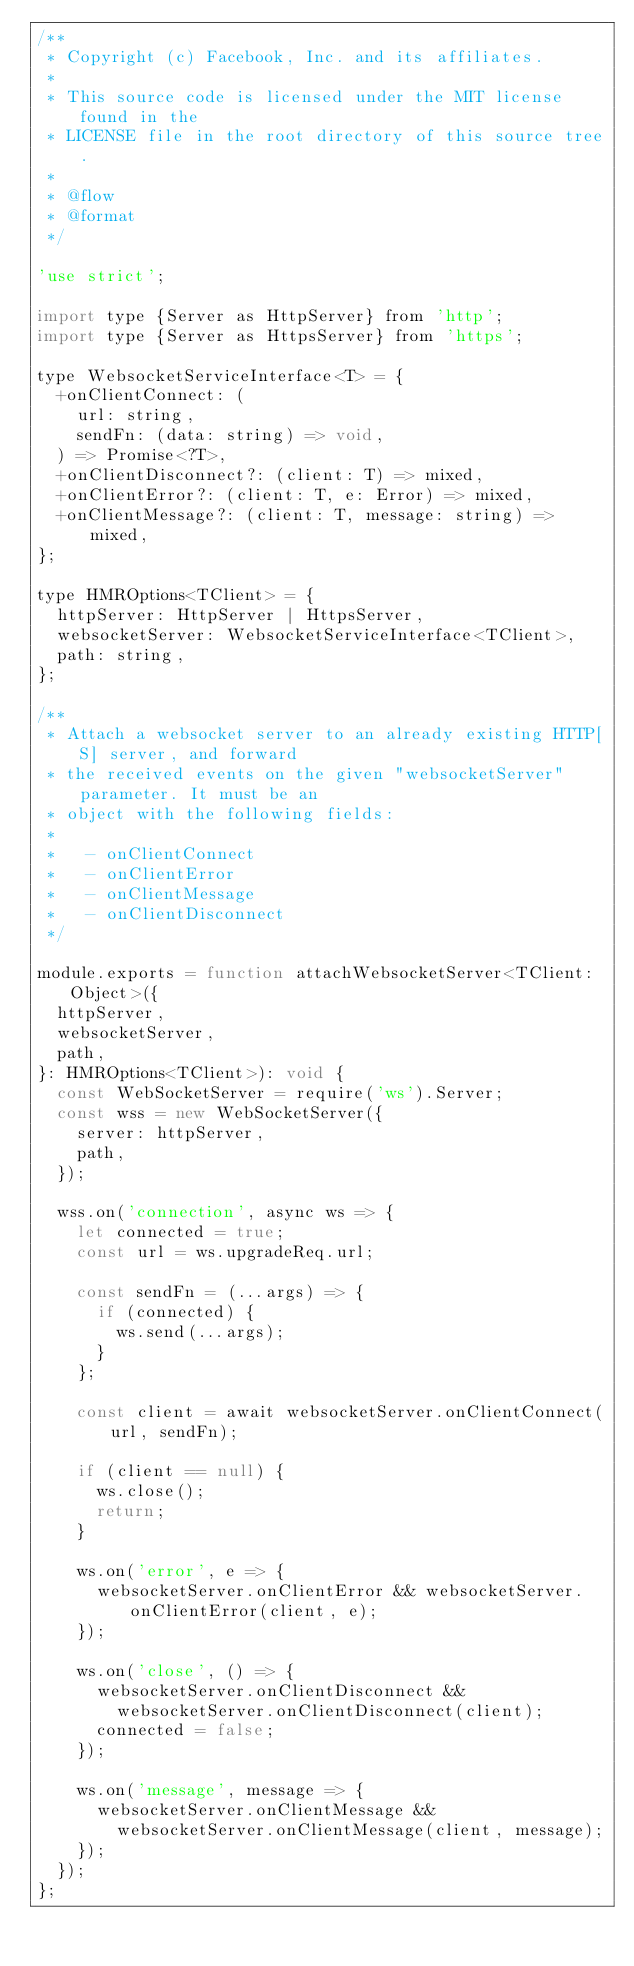Convert code to text. <code><loc_0><loc_0><loc_500><loc_500><_JavaScript_>/**
 * Copyright (c) Facebook, Inc. and its affiliates.
 *
 * This source code is licensed under the MIT license found in the
 * LICENSE file in the root directory of this source tree.
 *
 * @flow
 * @format
 */

'use strict';

import type {Server as HttpServer} from 'http';
import type {Server as HttpsServer} from 'https';

type WebsocketServiceInterface<T> = {
  +onClientConnect: (
    url: string,
    sendFn: (data: string) => void,
  ) => Promise<?T>,
  +onClientDisconnect?: (client: T) => mixed,
  +onClientError?: (client: T, e: Error) => mixed,
  +onClientMessage?: (client: T, message: string) => mixed,
};

type HMROptions<TClient> = {
  httpServer: HttpServer | HttpsServer,
  websocketServer: WebsocketServiceInterface<TClient>,
  path: string,
};

/**
 * Attach a websocket server to an already existing HTTP[S] server, and forward
 * the received events on the given "websocketServer" parameter. It must be an
 * object with the following fields:
 *
 *   - onClientConnect
 *   - onClientError
 *   - onClientMessage
 *   - onClientDisconnect
 */

module.exports = function attachWebsocketServer<TClient: Object>({
  httpServer,
  websocketServer,
  path,
}: HMROptions<TClient>): void {
  const WebSocketServer = require('ws').Server;
  const wss = new WebSocketServer({
    server: httpServer,
    path,
  });

  wss.on('connection', async ws => {
    let connected = true;
    const url = ws.upgradeReq.url;

    const sendFn = (...args) => {
      if (connected) {
        ws.send(...args);
      }
    };

    const client = await websocketServer.onClientConnect(url, sendFn);

    if (client == null) {
      ws.close();
      return;
    }

    ws.on('error', e => {
      websocketServer.onClientError && websocketServer.onClientError(client, e);
    });

    ws.on('close', () => {
      websocketServer.onClientDisconnect &&
        websocketServer.onClientDisconnect(client);
      connected = false;
    });

    ws.on('message', message => {
      websocketServer.onClientMessage &&
        websocketServer.onClientMessage(client, message);
    });
  });
};
</code> 